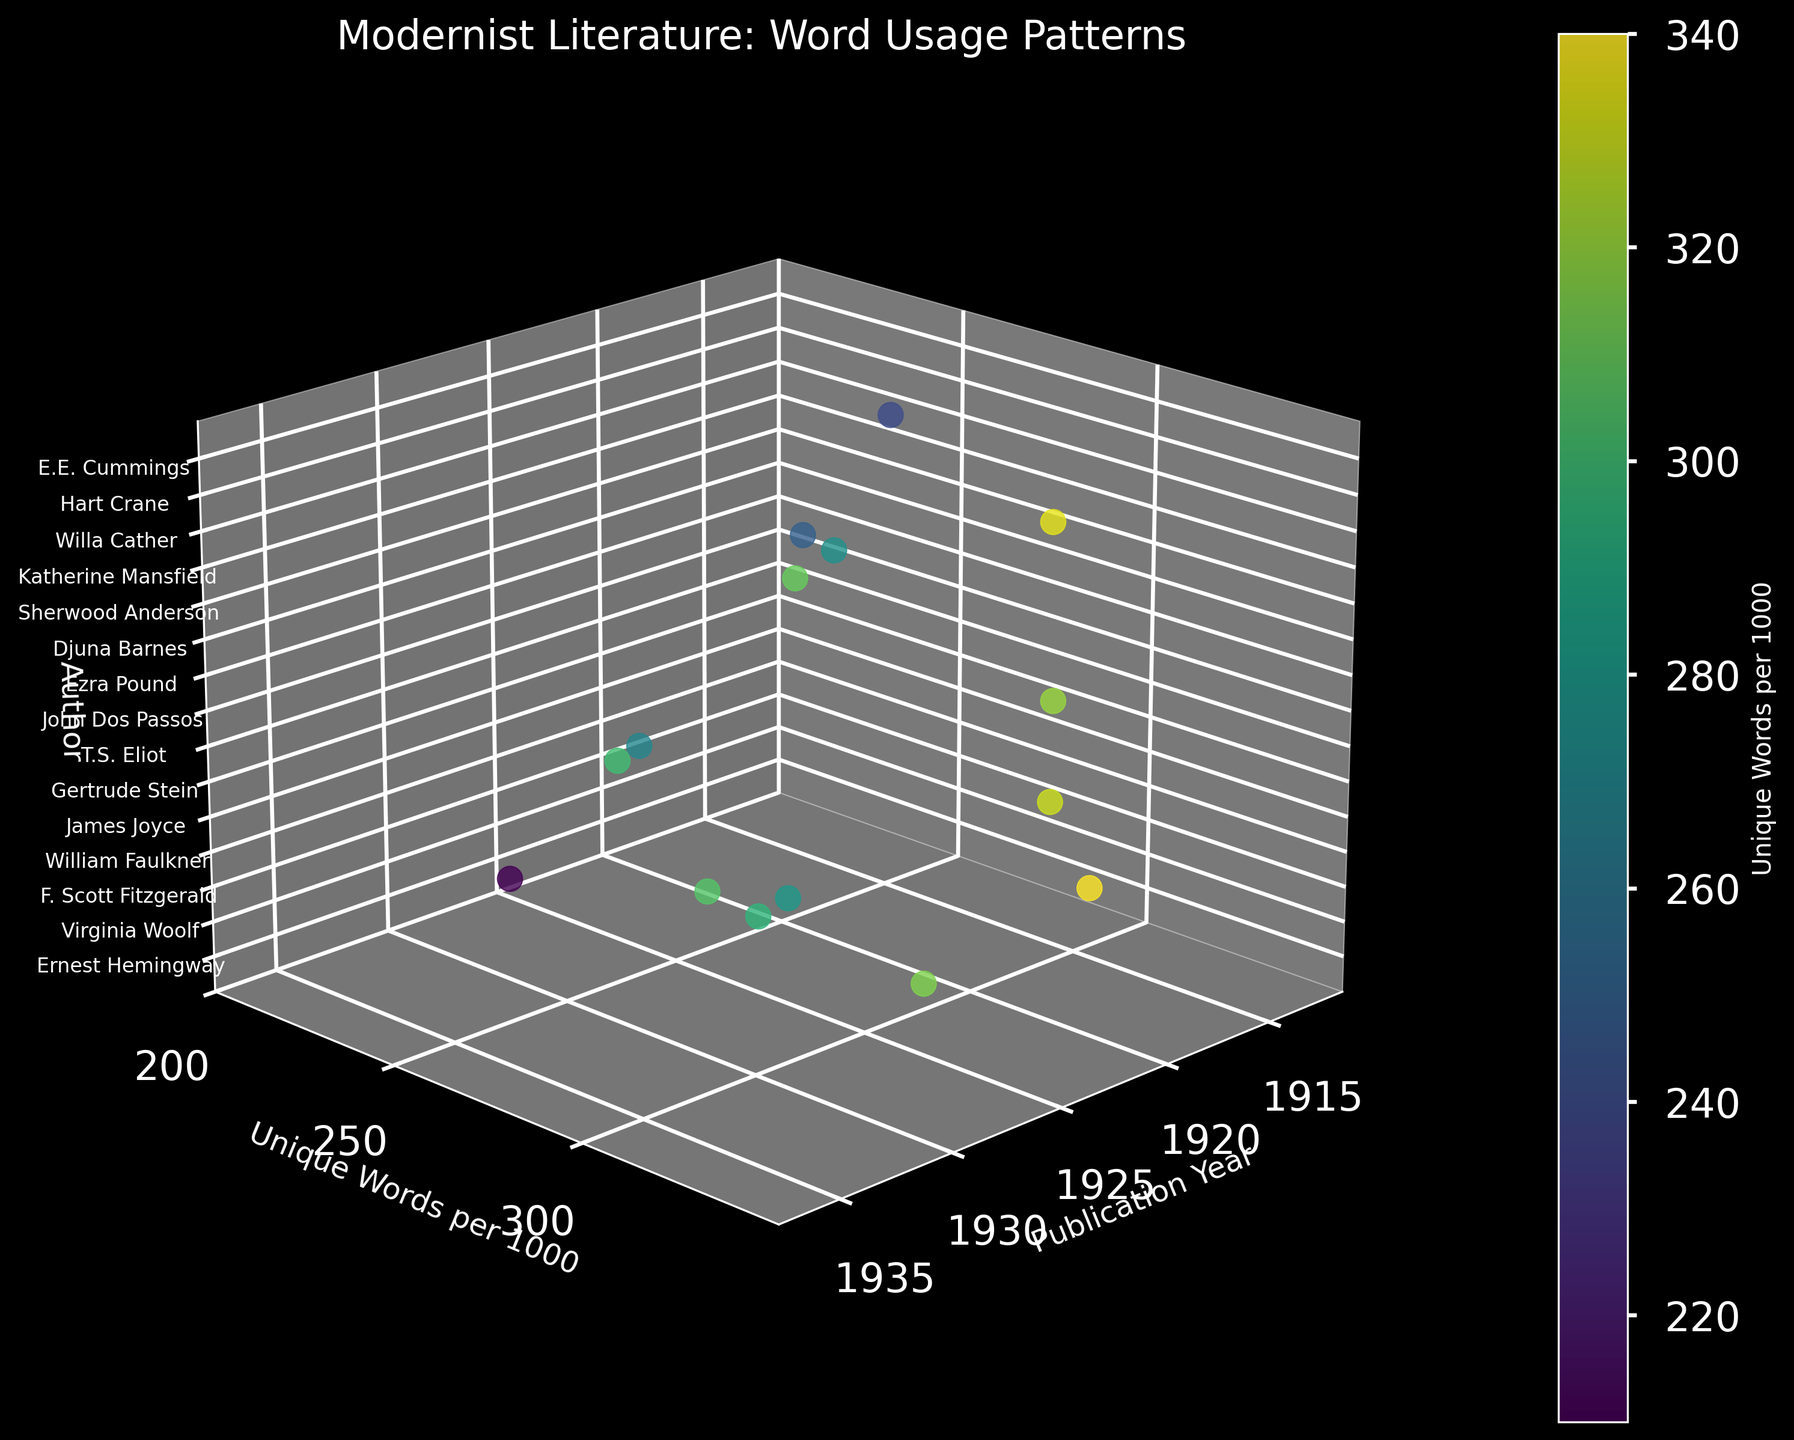Which author has the highest unique words per 1000 metric? By examining the y-axis, which represents Unique Words per 1000, and checking the data points, it's clear that James Joyce has the highest value at 340.
Answer: James Joyce What is the title of the figure? The title of the figure is typically located at the top center of the plot. Here, it reads "Modernist Literature: Word Usage Patterns".
Answer: Modernist Literature: Word Usage Patterns Which style is associated with the maximum y-axis value in the plot? To identify the style corresponding to the maximum y-axis value (340 unique words per 1000), check the author's name listed with this value and find their literary style in the data. James Joyce is linked with the Experimental style.
Answer: Experimental Around what range of publication years is most of the data clustered? The data points on the x-axis show publication years mostly ranging from the early 1920s to the mid-1930s, indicating that most data is clustered in this timeframe.
Answer: Early 1920s to mid-1930s How many authors are represented in the plot? The z-axis tick labels display all the authors included in the dataset. Count the number of distinct author names to determine the total. There are 15 authors in this plot.
Answer: 15 Which literary style has more unique words—Minimalism or Prairie Realism? Compare the y-axis values for the authors using the Minimalism and Prairie Realism styles. Ernest Hemingway (Minimalism) has 210 and Willa Cather (Prairie Realism) has 240. Hence, Prairie Realism has more unique words.
Answer: Prairie Realism What's the difference in unique words per 1000 between E.E. Cummings and Djuna Barnes? E.E. Cummings has 335 unique words per 1000 and Djuna Barnes has 300. The difference is 335 - 300 = 35.
Answer: 35 Which publication year corresponds to the author with the lowest unique words per 1000? Identify the data point with the lowest y-axis value and find the corresponding author and publication year. Willa Cather has the lowest value at 240, published in 1913.
Answer: 1913 How does the unique word usage of Virginia Woolf compare to that of T.S. Eliot? Virginia Woolf's value is 315 unique words per 1000, whereas T.S. Eliot's is 330. Thus, T.S. Eliot has a higher usage than Virginia Woolf.
Answer: T.S. Eliot has higher usage What color represents the highest range of y-axis values on the plot? The color bar shows the range of y-axis values with different colors. For the highest range, which corresponds to around 340 unique words per 1000, the color indicated is a bright yellowish-green.
Answer: Bright yellowish-green 